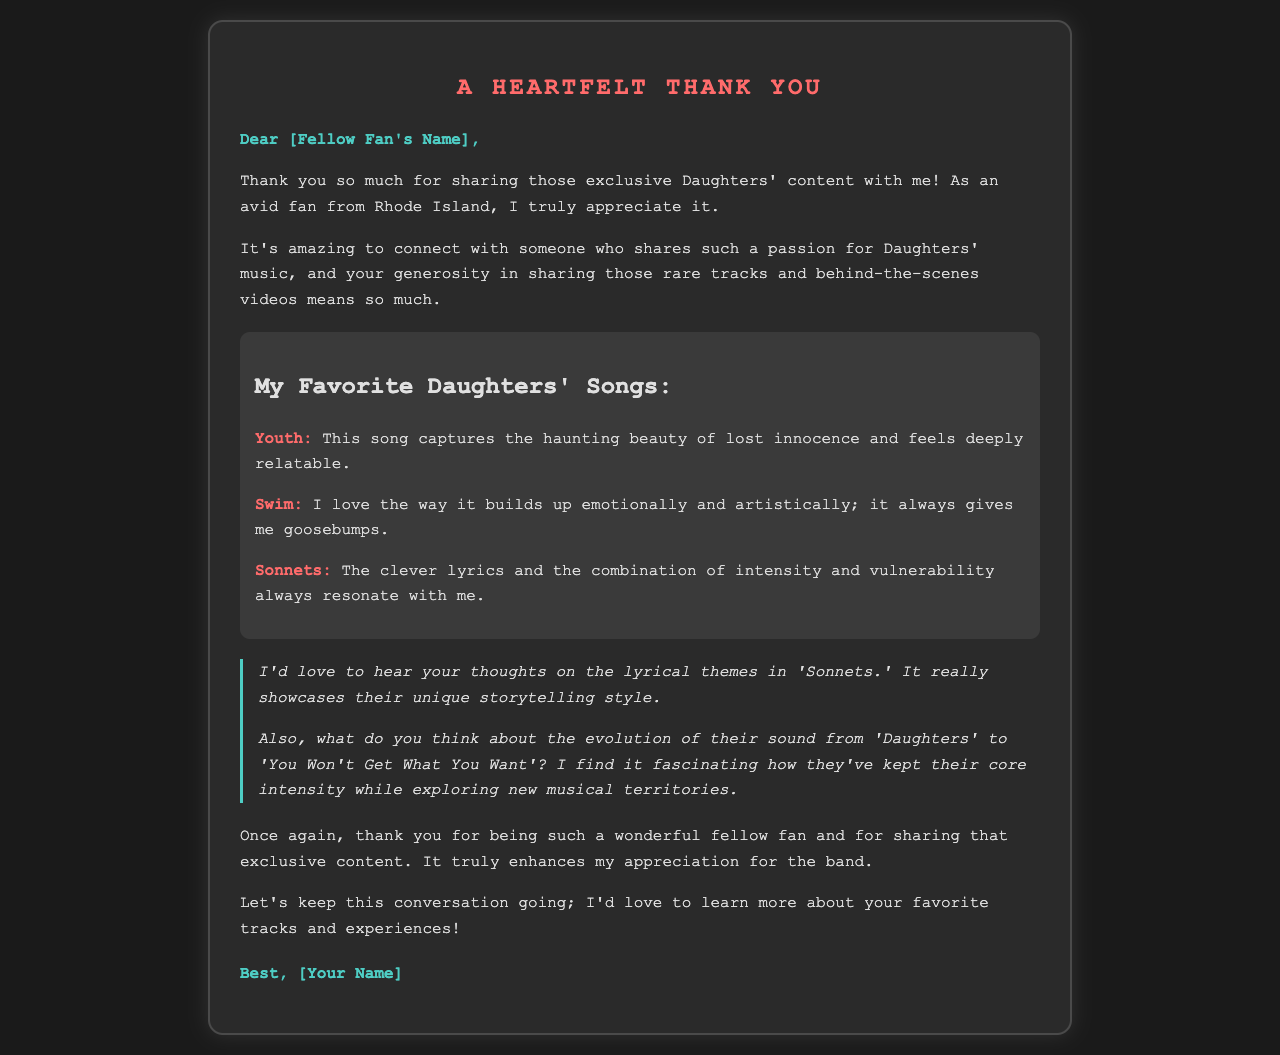What is the recipient's name? The document uses a placeholder indicating that a name should be inserted.
Answer: [Fellow Fan's Name] What song reflects the theme of lost innocence? The document mentions a song that captures this theme.
Answer: Youth Which song gives the author goosebumps? The letter states that a particular song builds up emotionally and gives goosebumps.
Answer: Swim What song showcases Daughters' unique storytelling style? The author expresses interest in discussing the lyrical themes of a specific song.
Answer: Sonnets How does the author feel about Daughters' evolution of sound? The letter reflects on their development while maintaining intensity.
Answer: Fascinating What is the overall sentiment expressed in the letter? The appreciation for shared content and connection with the fellow fan is evident throughout the document.
Answer: Gratitude What is the closing remark in the letter? The letter ends with a message encouraging ongoing conversation.
Answer: Let's keep this conversation going What color is used for the song titles in the letter? The document describes the styling of the song titles with a specific color.
Answer: #ff6b6b What is the author’s location? The letter mentions where the author lives.
Answer: Rhode Island 